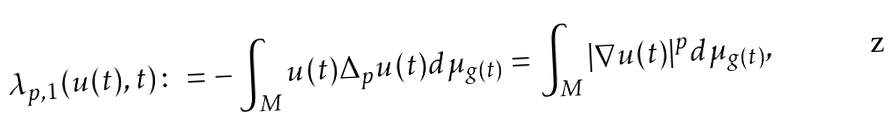<formula> <loc_0><loc_0><loc_500><loc_500>\lambda _ { p , 1 } ( u ( t ) , t ) \colon = - \int _ { M } u ( t ) \Delta _ { p } u ( t ) d \mu _ { g ( t ) } = \int _ { M } | \nabla u ( t ) | ^ { p } d \mu _ { g ( t ) } ,</formula> 